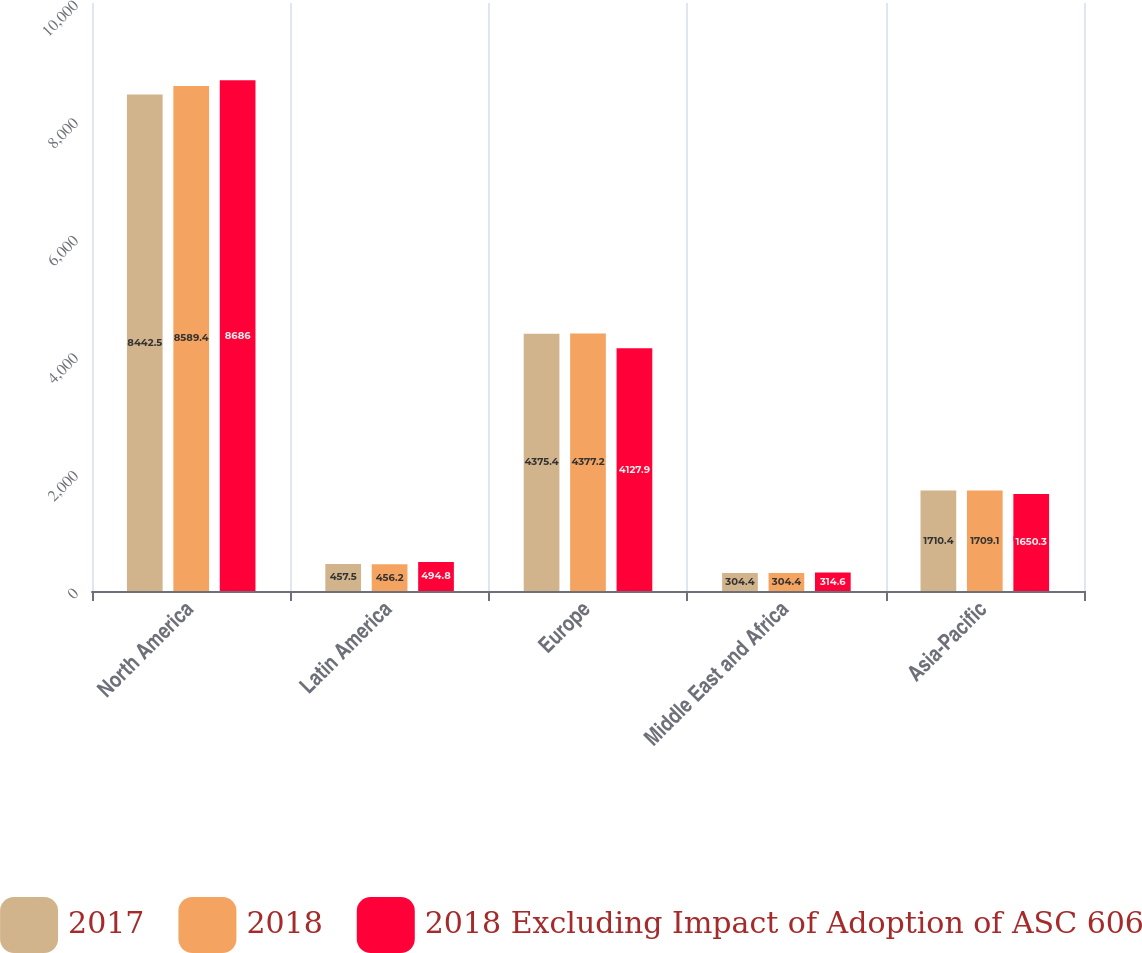<chart> <loc_0><loc_0><loc_500><loc_500><stacked_bar_chart><ecel><fcel>North America<fcel>Latin America<fcel>Europe<fcel>Middle East and Africa<fcel>Asia-Pacific<nl><fcel>2017<fcel>8442.5<fcel>457.5<fcel>4375.4<fcel>304.4<fcel>1710.4<nl><fcel>2018<fcel>8589.4<fcel>456.2<fcel>4377.2<fcel>304.4<fcel>1709.1<nl><fcel>2018 Excluding Impact of Adoption of ASC 606<fcel>8686<fcel>494.8<fcel>4127.9<fcel>314.6<fcel>1650.3<nl></chart> 